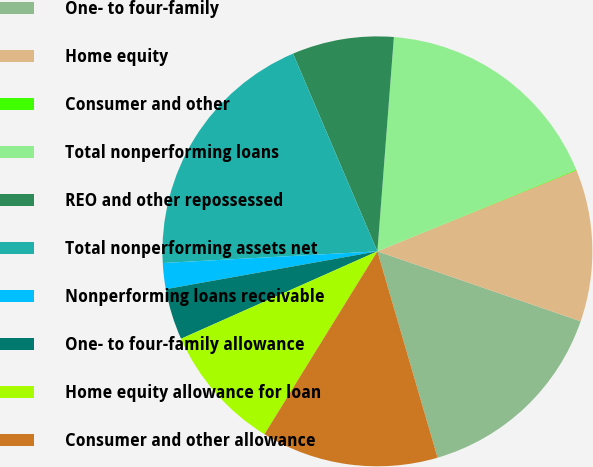Convert chart. <chart><loc_0><loc_0><loc_500><loc_500><pie_chart><fcel>One- to four-family<fcel>Home equity<fcel>Consumer and other<fcel>Total nonperforming loans<fcel>REO and other repossessed<fcel>Total nonperforming assets net<fcel>Nonperforming loans receivable<fcel>One- to four-family allowance<fcel>Home equity allowance for loan<fcel>Consumer and other allowance<nl><fcel>15.21%<fcel>11.43%<fcel>0.06%<fcel>17.56%<fcel>7.64%<fcel>19.45%<fcel>1.95%<fcel>3.85%<fcel>9.53%<fcel>13.32%<nl></chart> 